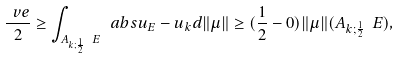Convert formula to latex. <formula><loc_0><loc_0><loc_500><loc_500>\frac { \ v e } { 2 } \geq \int _ { A _ { k ; \frac { 1 } { 2 } } \ E } \ a b s { u _ { E } - u _ { k } } d { \| \mu \| } \geq ( \frac { 1 } { 2 } - 0 ) { \| \mu \| } ( A _ { k ; \frac { 1 } { 2 } } \ E ) ,</formula> 